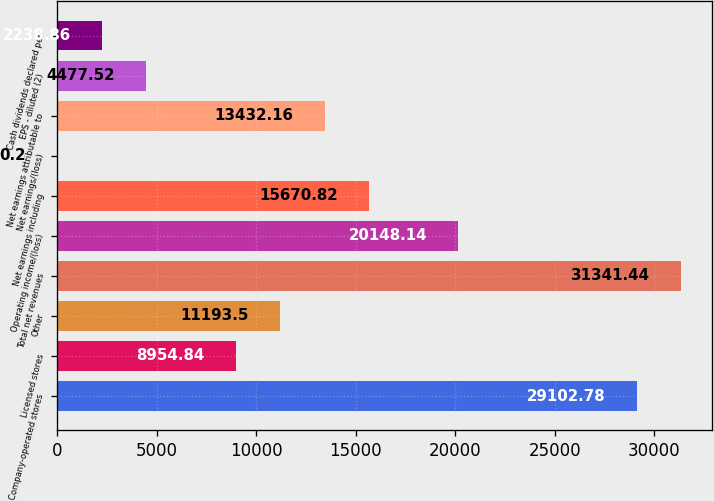Convert chart. <chart><loc_0><loc_0><loc_500><loc_500><bar_chart><fcel>Company-operated stores<fcel>Licensed stores<fcel>Other<fcel>Total net revenues<fcel>Operating income/(loss)<fcel>Net earnings including<fcel>Net earnings/(loss)<fcel>Net earnings attributable to<fcel>EPS - diluted (2)<fcel>Cash dividends declared per<nl><fcel>29102.8<fcel>8954.84<fcel>11193.5<fcel>31341.4<fcel>20148.1<fcel>15670.8<fcel>0.2<fcel>13432.2<fcel>4477.52<fcel>2238.86<nl></chart> 